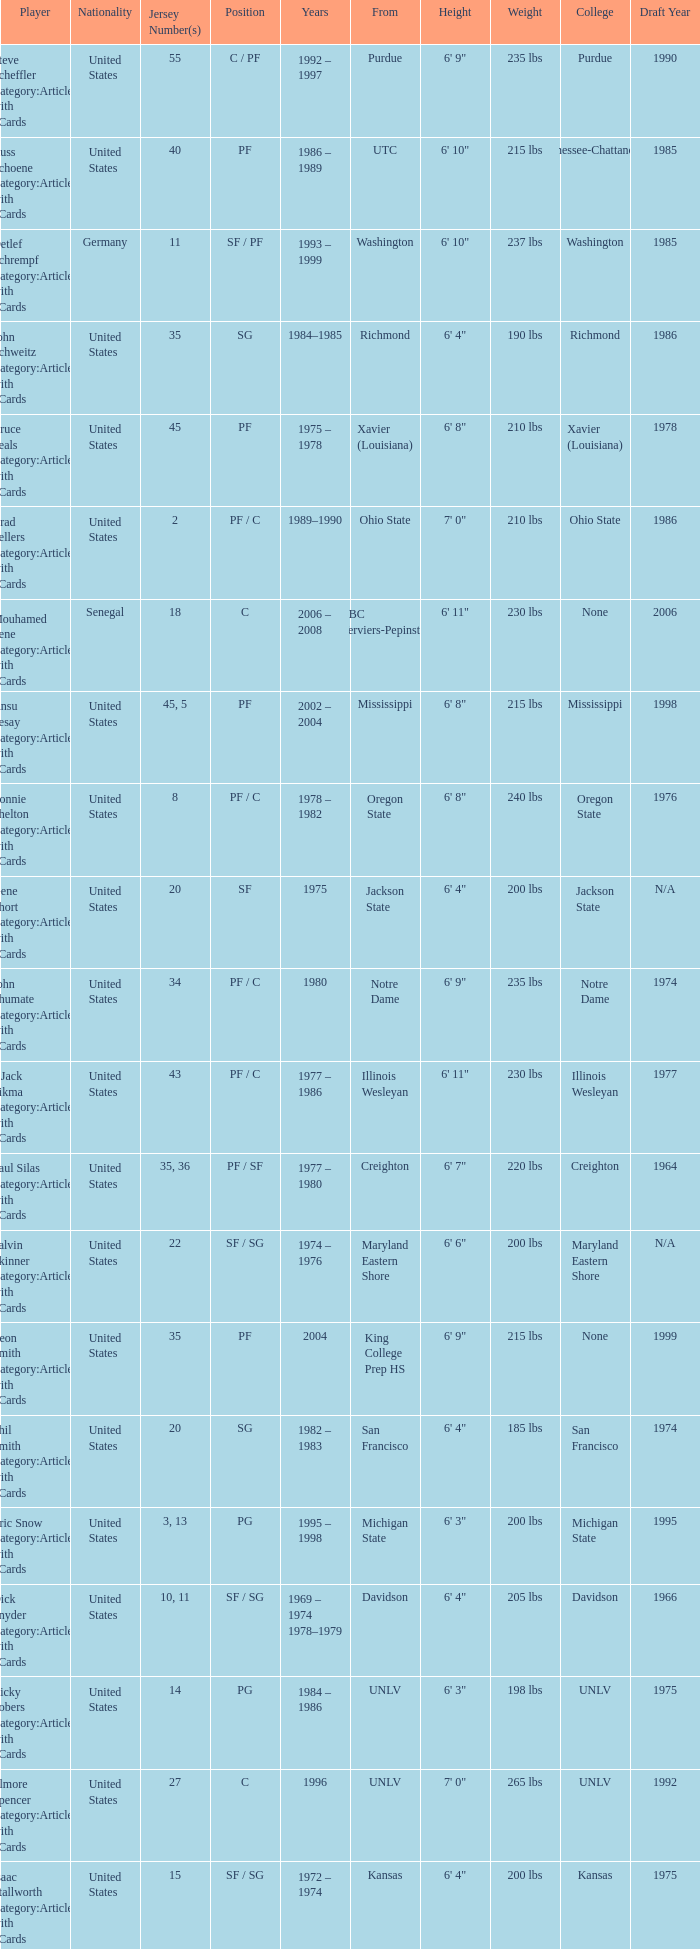What nationality is the player from Oregon State? United States. 